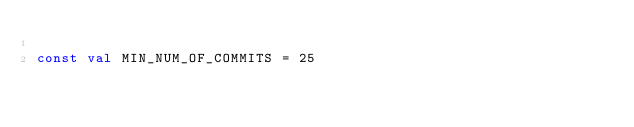Convert code to text. <code><loc_0><loc_0><loc_500><loc_500><_Kotlin_>
const val MIN_NUM_OF_COMMITS = 25</code> 